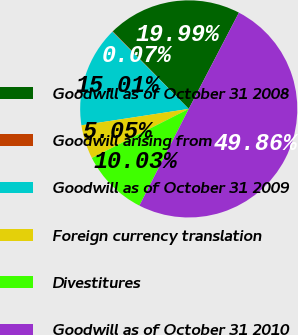Convert chart. <chart><loc_0><loc_0><loc_500><loc_500><pie_chart><fcel>Goodwill as of October 31 2008<fcel>Goodwill arising from<fcel>Goodwill as of October 31 2009<fcel>Foreign currency translation<fcel>Divestitures<fcel>Goodwill as of October 31 2010<nl><fcel>19.99%<fcel>0.07%<fcel>15.01%<fcel>5.05%<fcel>10.03%<fcel>49.87%<nl></chart> 